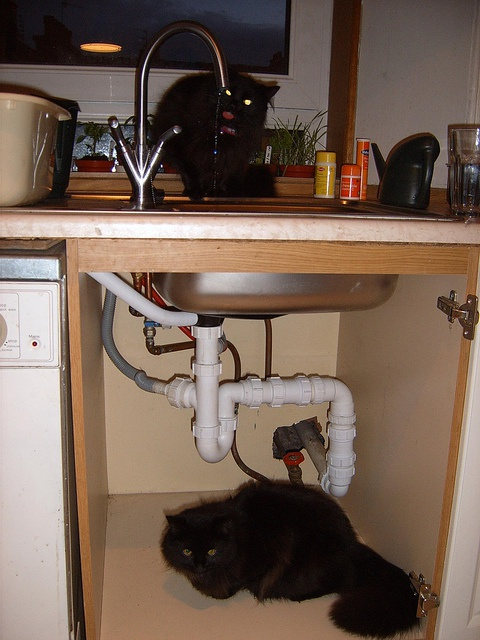Describe the objects in this image and their specific colors. I can see cat in black, maroon, and gray tones, sink in black, maroon, and gray tones, cat in black, gray, and maroon tones, potted plant in black, gray, maroon, and darkgreen tones, and cup in black, gray, and maroon tones in this image. 